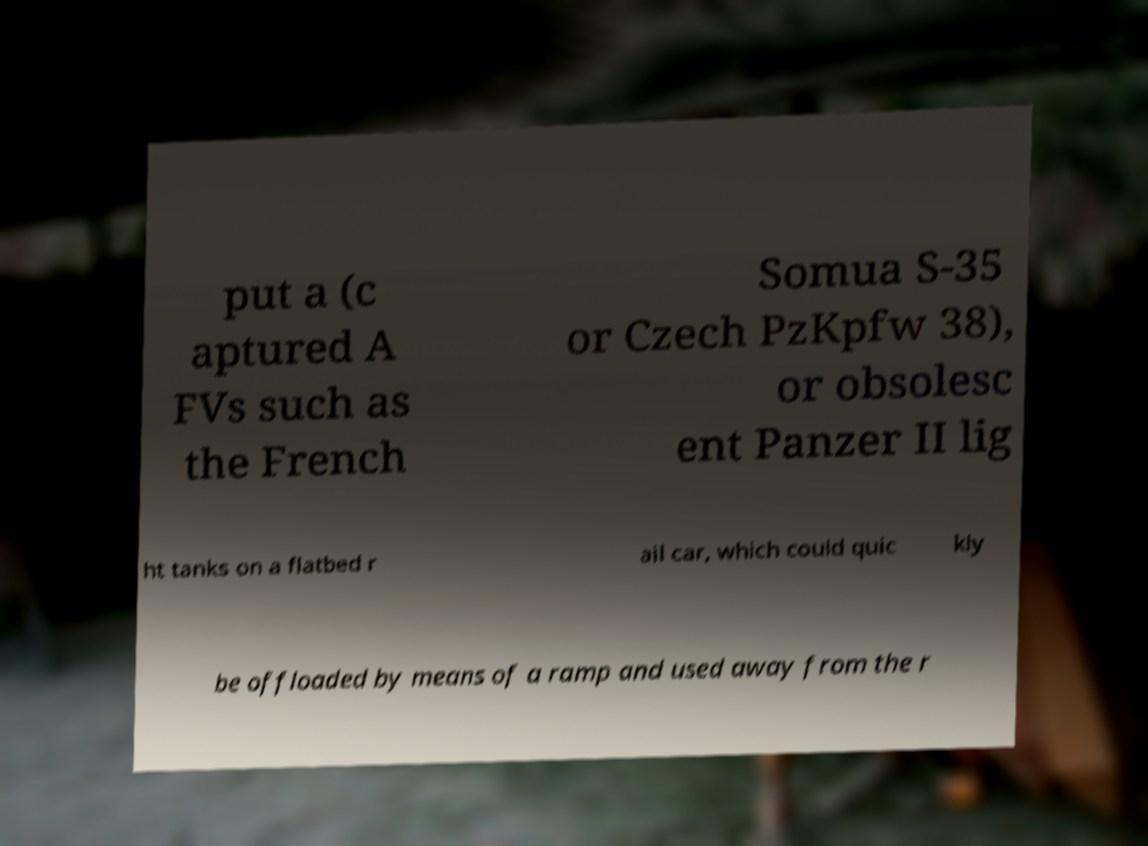Can you accurately transcribe the text from the provided image for me? put a (c aptured A FVs such as the French Somua S-35 or Czech PzKpfw 38), or obsolesc ent Panzer II lig ht tanks on a flatbed r ail car, which could quic kly be offloaded by means of a ramp and used away from the r 